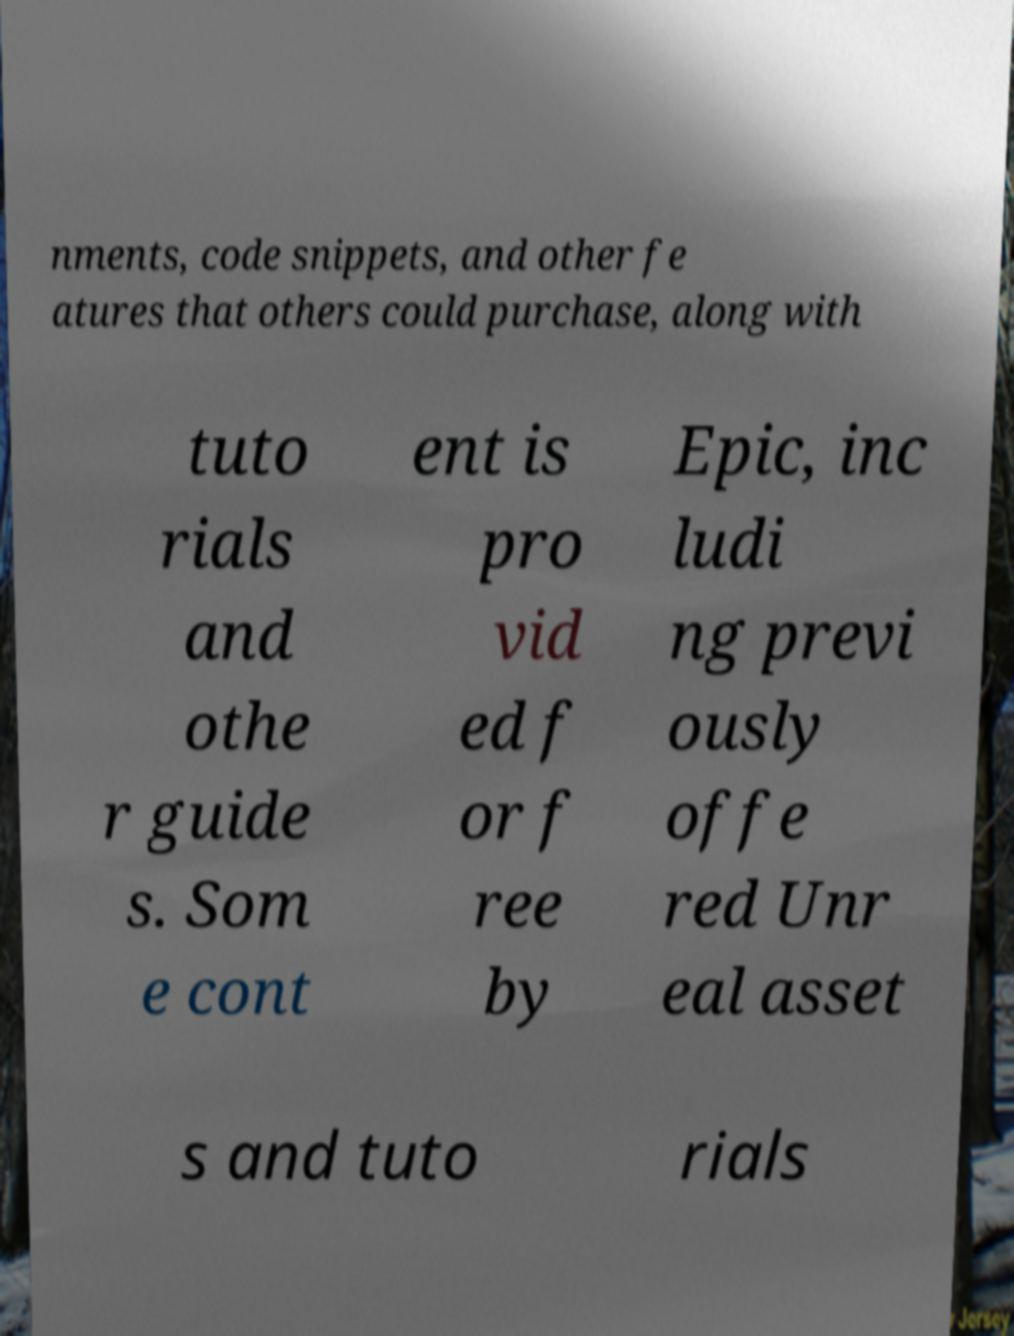Could you extract and type out the text from this image? nments, code snippets, and other fe atures that others could purchase, along with tuto rials and othe r guide s. Som e cont ent is pro vid ed f or f ree by Epic, inc ludi ng previ ously offe red Unr eal asset s and tuto rials 